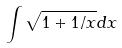<formula> <loc_0><loc_0><loc_500><loc_500>\int \sqrt { 1 + 1 / x } d x</formula> 